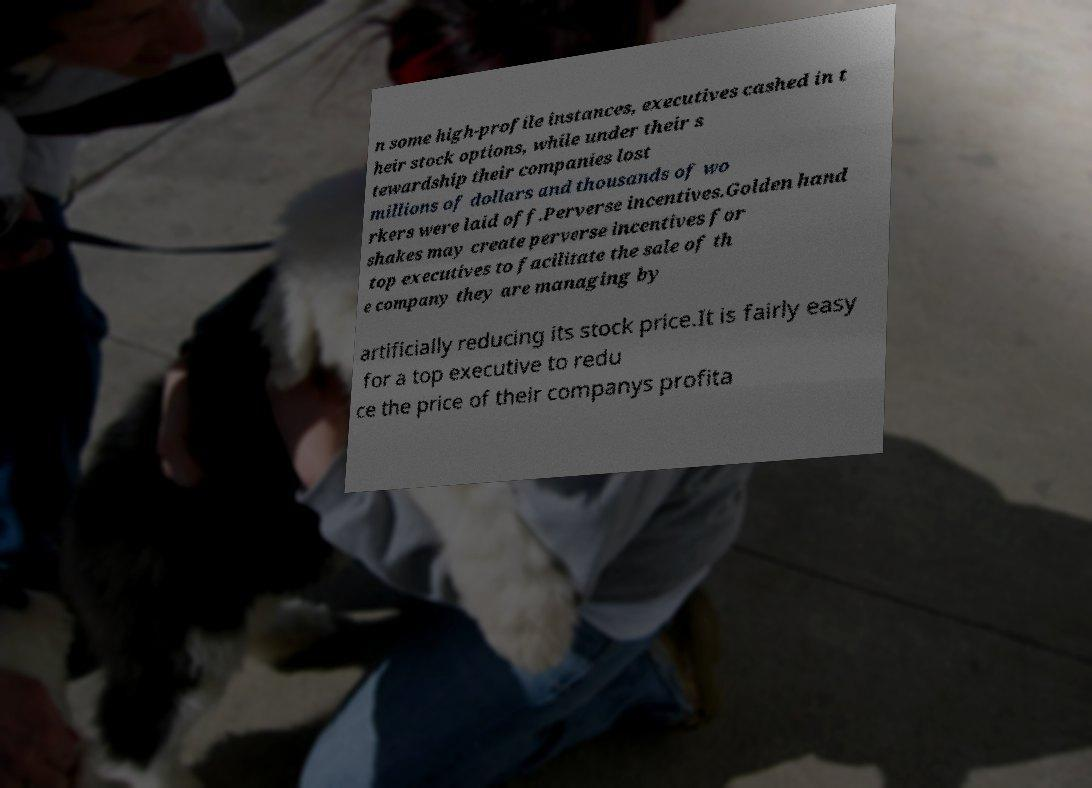There's text embedded in this image that I need extracted. Can you transcribe it verbatim? n some high-profile instances, executives cashed in t heir stock options, while under their s tewardship their companies lost millions of dollars and thousands of wo rkers were laid off.Perverse incentives.Golden hand shakes may create perverse incentives for top executives to facilitate the sale of th e company they are managing by artificially reducing its stock price.It is fairly easy for a top executive to redu ce the price of their companys profita 